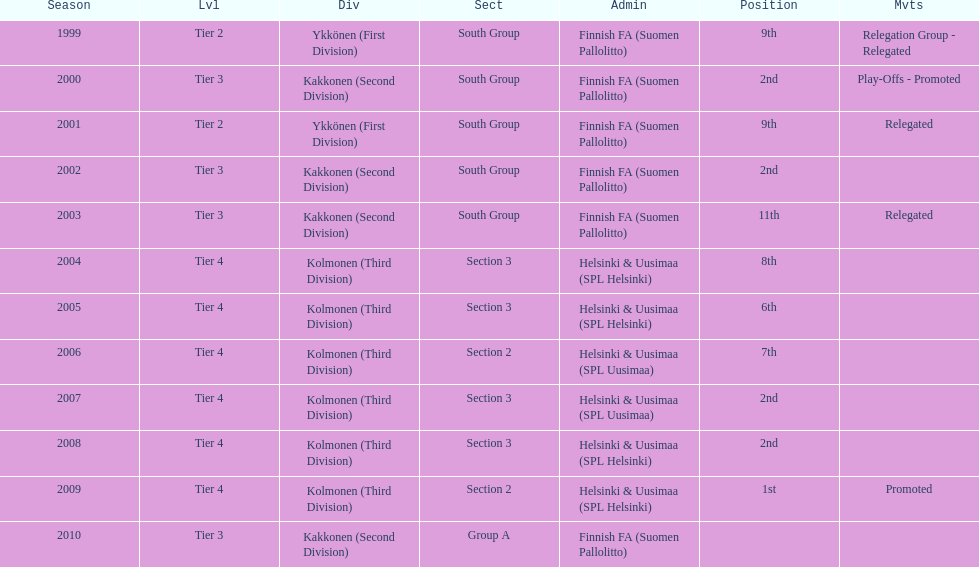How many tiers had more than one relegated movement? 1. 